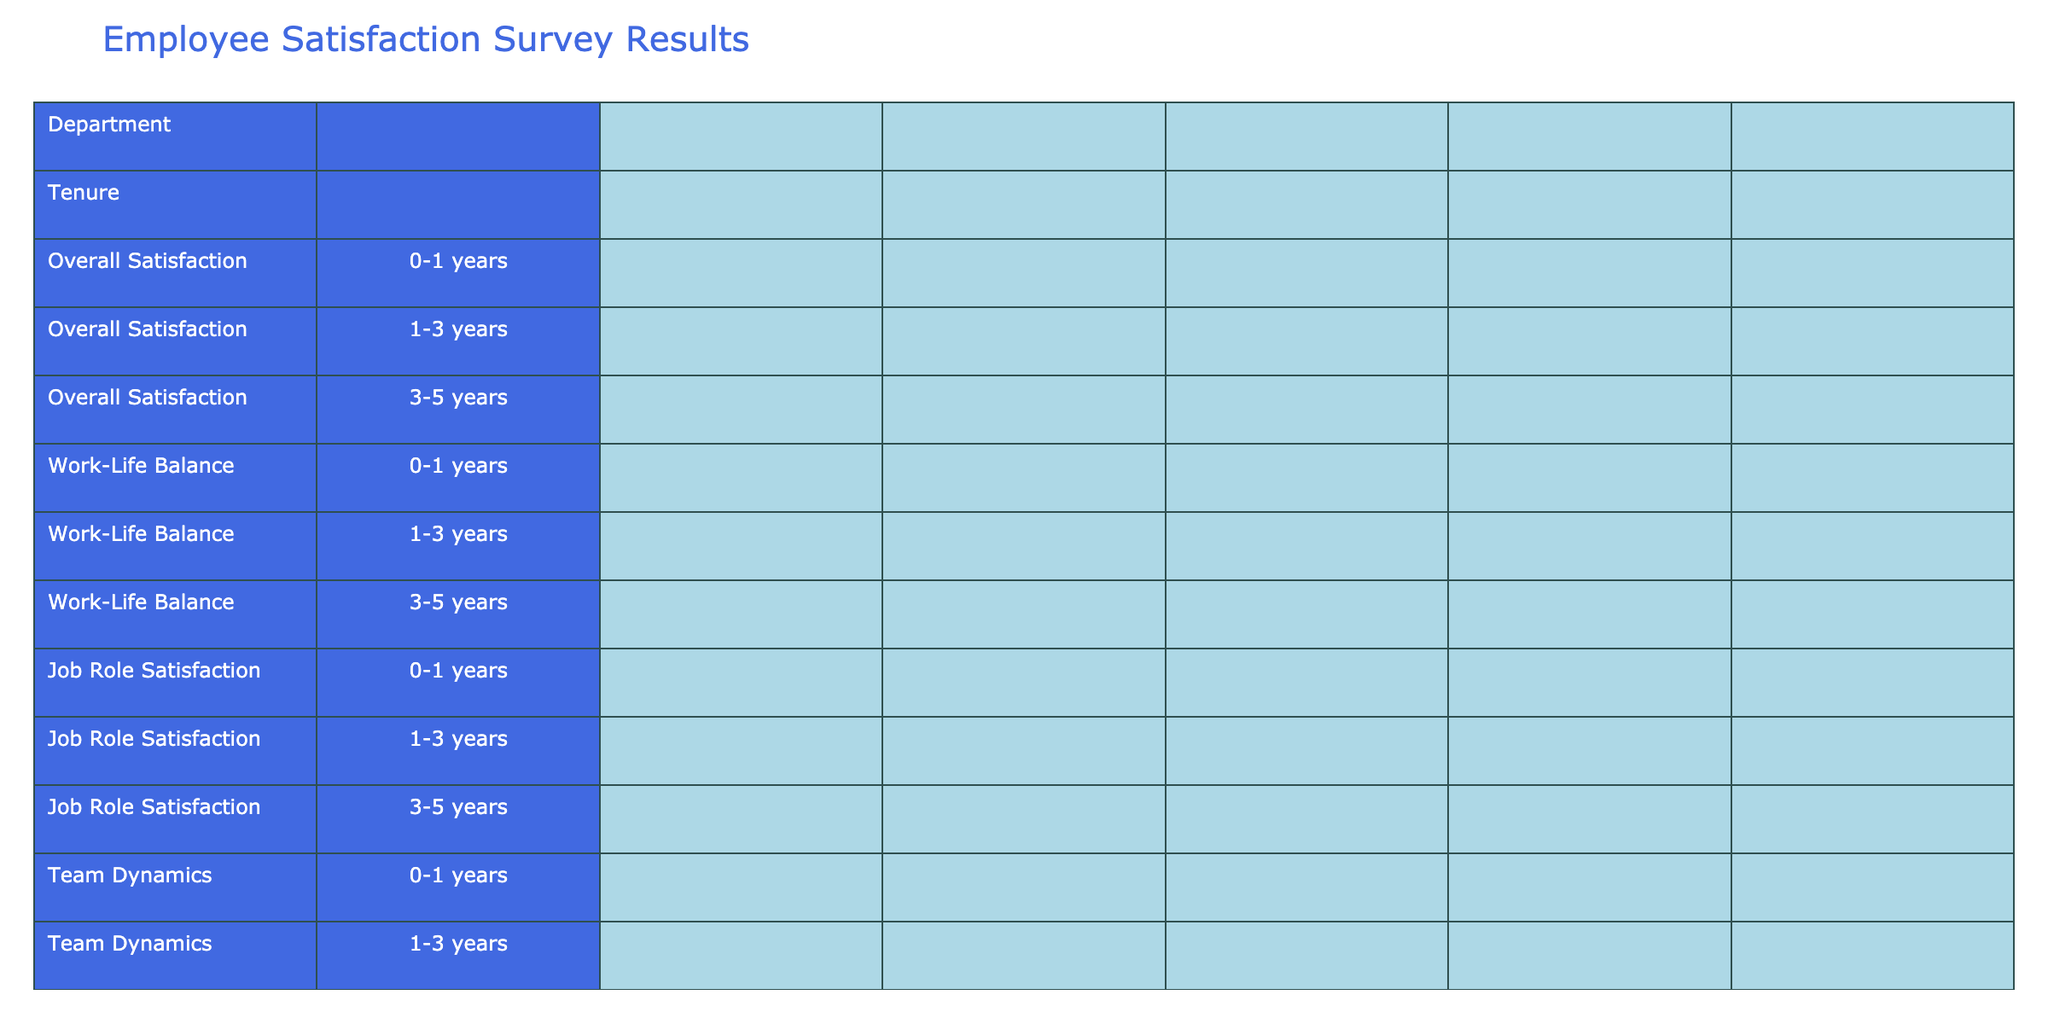What's the overall satisfaction score for the HR department with 3-5 years of tenure? By referring to the table, I identify the row for the HR department and tenure of 3-5 years. The overall satisfaction score listed there is 5.
Answer: 5 Which department has the lowest average work-life balance score across all tenures? To find this, I need to calculate the average work-life balance score for each department. For example, Sales has scores of 4, 4, and 5, averaging 4.33. Repeating this for all departments, Marketing has the lowest average at 3.67 (2+3+4) / 3.
Answer: Marketing Is it true that employees in Finance with 1-3 years of tenure are more satisfied with job roles than those in IT with the same tenure? I compare the job role satisfaction score for Finance (4) and IT (4). Since these scores are equal, it is false that Finance employees are more satisfied.
Answer: No What is the difference in team dynamics scores between the Sales department with 0-1 years and the HR department with 0-1 years? The team dynamics score for Sales (4) and for HR (4) are both equal. Therefore, the difference in scores is 0.
Answer: 0 Which department has the highest opportunities for growth score among employees with 1-3 years of tenure? By examining the 1-3 year tenure section, I notice that Finance has a score of 4, Marketing has a score of 3, and HR has a score of 3, while IT has a score of 3. Hence, Finance has the highest score at 4.
Answer: Finance For employees in Customer Service with 3-5 years of tenure, how does their recognition score compare to that of IT employees with the same tenure? In the Customer Service department, the recognition score is 4, while in IT, the recognition score is also 4. Therefore, they are identical.
Answer: Same (4) Which tenure category has the highest overall satisfaction score in the Sales department? Looking at the Sales department, the scores for different tenures are 3, 4, and 5 for 0-1, 1-3, and 3-5 years respectively. The highest score is 5 for the 3-5 years category.
Answer: 3-5 years If we look at the average recognition score for all tenures in the Marketing department, what is it? The recognition scores for Marketing are 3, 4, and 3 across the tenures. Adding these gives 10, and dividing by 3 yields an average of approximately 3.33.
Answer: 3.33 Are employees with 0-1 years of tenure more satisfied with their jobs in HR compared to those in Customer Service? For HR, the job role satisfaction score is 3, while for Customer Service, it is the same at 3. Hence, they are equal, and the statement is false.
Answer: No What is the trend in overall satisfaction scores across tenures for the Marketing department? Reviewing the scores for Marketing gives 2, 3, and 4 for the tenures of 0-1, 1-3, and 3-5 years, respectively. The trend shows an increase from 2 to 4 as tenure increases.
Answer: Increasing 